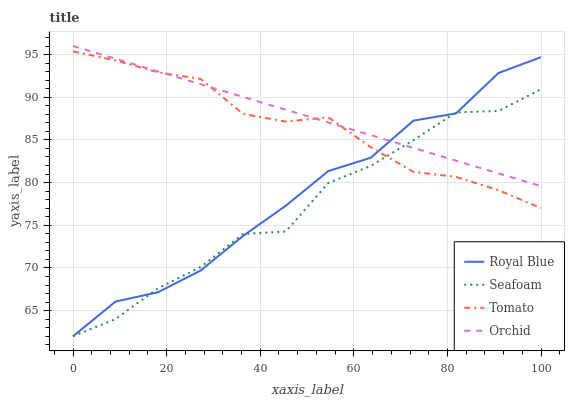Does Seafoam have the minimum area under the curve?
Answer yes or no. Yes. Does Orchid have the maximum area under the curve?
Answer yes or no. Yes. Does Royal Blue have the minimum area under the curve?
Answer yes or no. No. Does Royal Blue have the maximum area under the curve?
Answer yes or no. No. Is Orchid the smoothest?
Answer yes or no. Yes. Is Seafoam the roughest?
Answer yes or no. Yes. Is Royal Blue the smoothest?
Answer yes or no. No. Is Royal Blue the roughest?
Answer yes or no. No. Does Orchid have the lowest value?
Answer yes or no. No. Does Orchid have the highest value?
Answer yes or no. Yes. Does Royal Blue have the highest value?
Answer yes or no. No. Does Orchid intersect Tomato?
Answer yes or no. Yes. Is Orchid less than Tomato?
Answer yes or no. No. Is Orchid greater than Tomato?
Answer yes or no. No. 